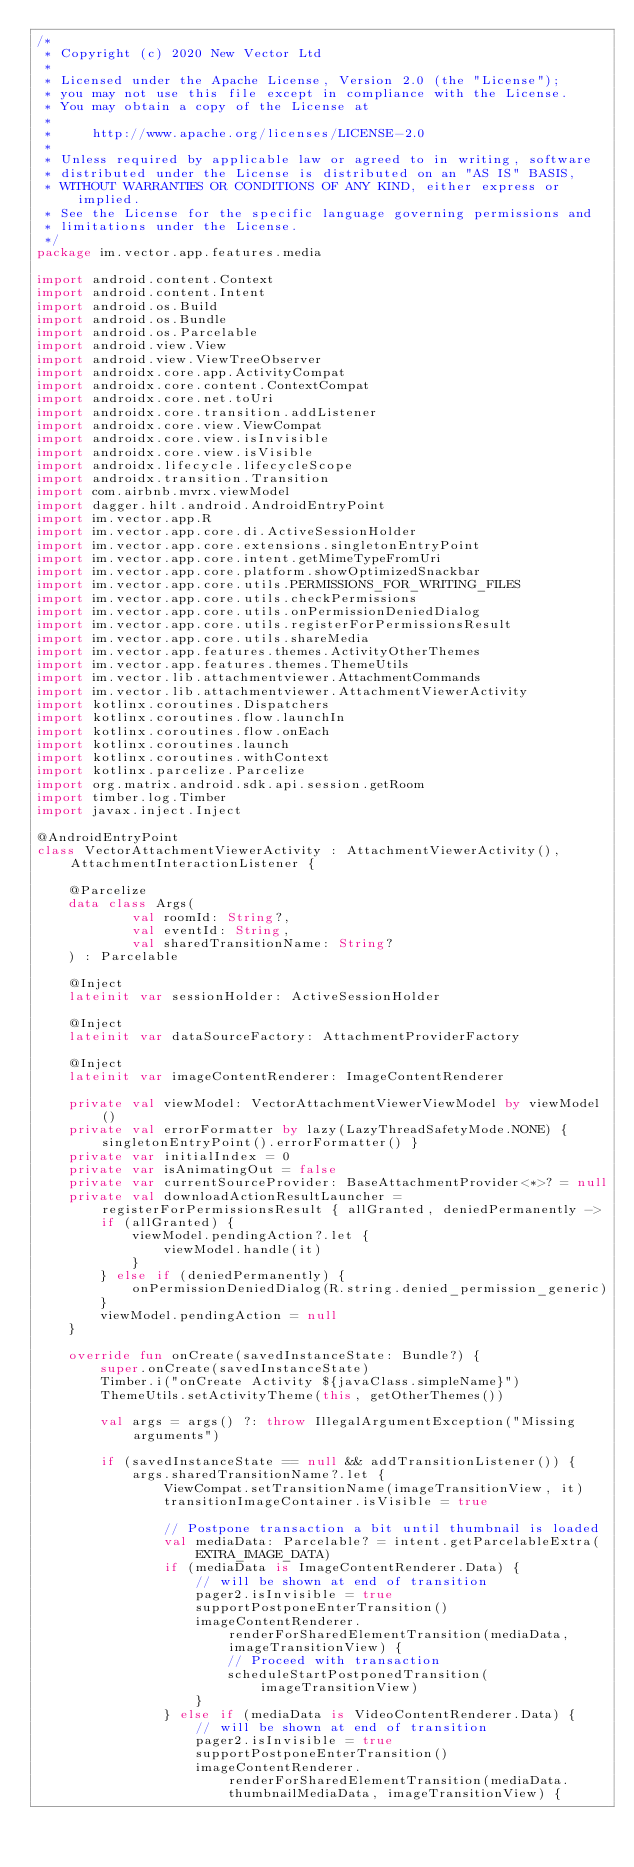Convert code to text. <code><loc_0><loc_0><loc_500><loc_500><_Kotlin_>/*
 * Copyright (c) 2020 New Vector Ltd
 *
 * Licensed under the Apache License, Version 2.0 (the "License");
 * you may not use this file except in compliance with the License.
 * You may obtain a copy of the License at
 *
 *     http://www.apache.org/licenses/LICENSE-2.0
 *
 * Unless required by applicable law or agreed to in writing, software
 * distributed under the License is distributed on an "AS IS" BASIS,
 * WITHOUT WARRANTIES OR CONDITIONS OF ANY KIND, either express or implied.
 * See the License for the specific language governing permissions and
 * limitations under the License.
 */
package im.vector.app.features.media

import android.content.Context
import android.content.Intent
import android.os.Build
import android.os.Bundle
import android.os.Parcelable
import android.view.View
import android.view.ViewTreeObserver
import androidx.core.app.ActivityCompat
import androidx.core.content.ContextCompat
import androidx.core.net.toUri
import androidx.core.transition.addListener
import androidx.core.view.ViewCompat
import androidx.core.view.isInvisible
import androidx.core.view.isVisible
import androidx.lifecycle.lifecycleScope
import androidx.transition.Transition
import com.airbnb.mvrx.viewModel
import dagger.hilt.android.AndroidEntryPoint
import im.vector.app.R
import im.vector.app.core.di.ActiveSessionHolder
import im.vector.app.core.extensions.singletonEntryPoint
import im.vector.app.core.intent.getMimeTypeFromUri
import im.vector.app.core.platform.showOptimizedSnackbar
import im.vector.app.core.utils.PERMISSIONS_FOR_WRITING_FILES
import im.vector.app.core.utils.checkPermissions
import im.vector.app.core.utils.onPermissionDeniedDialog
import im.vector.app.core.utils.registerForPermissionsResult
import im.vector.app.core.utils.shareMedia
import im.vector.app.features.themes.ActivityOtherThemes
import im.vector.app.features.themes.ThemeUtils
import im.vector.lib.attachmentviewer.AttachmentCommands
import im.vector.lib.attachmentviewer.AttachmentViewerActivity
import kotlinx.coroutines.Dispatchers
import kotlinx.coroutines.flow.launchIn
import kotlinx.coroutines.flow.onEach
import kotlinx.coroutines.launch
import kotlinx.coroutines.withContext
import kotlinx.parcelize.Parcelize
import org.matrix.android.sdk.api.session.getRoom
import timber.log.Timber
import javax.inject.Inject

@AndroidEntryPoint
class VectorAttachmentViewerActivity : AttachmentViewerActivity(), AttachmentInteractionListener {

    @Parcelize
    data class Args(
            val roomId: String?,
            val eventId: String,
            val sharedTransitionName: String?
    ) : Parcelable

    @Inject
    lateinit var sessionHolder: ActiveSessionHolder

    @Inject
    lateinit var dataSourceFactory: AttachmentProviderFactory

    @Inject
    lateinit var imageContentRenderer: ImageContentRenderer

    private val viewModel: VectorAttachmentViewerViewModel by viewModel()
    private val errorFormatter by lazy(LazyThreadSafetyMode.NONE) { singletonEntryPoint().errorFormatter() }
    private var initialIndex = 0
    private var isAnimatingOut = false
    private var currentSourceProvider: BaseAttachmentProvider<*>? = null
    private val downloadActionResultLauncher = registerForPermissionsResult { allGranted, deniedPermanently ->
        if (allGranted) {
            viewModel.pendingAction?.let {
                viewModel.handle(it)
            }
        } else if (deniedPermanently) {
            onPermissionDeniedDialog(R.string.denied_permission_generic)
        }
        viewModel.pendingAction = null
    }

    override fun onCreate(savedInstanceState: Bundle?) {
        super.onCreate(savedInstanceState)
        Timber.i("onCreate Activity ${javaClass.simpleName}")
        ThemeUtils.setActivityTheme(this, getOtherThemes())

        val args = args() ?: throw IllegalArgumentException("Missing arguments")

        if (savedInstanceState == null && addTransitionListener()) {
            args.sharedTransitionName?.let {
                ViewCompat.setTransitionName(imageTransitionView, it)
                transitionImageContainer.isVisible = true

                // Postpone transaction a bit until thumbnail is loaded
                val mediaData: Parcelable? = intent.getParcelableExtra(EXTRA_IMAGE_DATA)
                if (mediaData is ImageContentRenderer.Data) {
                    // will be shown at end of transition
                    pager2.isInvisible = true
                    supportPostponeEnterTransition()
                    imageContentRenderer.renderForSharedElementTransition(mediaData, imageTransitionView) {
                        // Proceed with transaction
                        scheduleStartPostponedTransition(imageTransitionView)
                    }
                } else if (mediaData is VideoContentRenderer.Data) {
                    // will be shown at end of transition
                    pager2.isInvisible = true
                    supportPostponeEnterTransition()
                    imageContentRenderer.renderForSharedElementTransition(mediaData.thumbnailMediaData, imageTransitionView) {</code> 